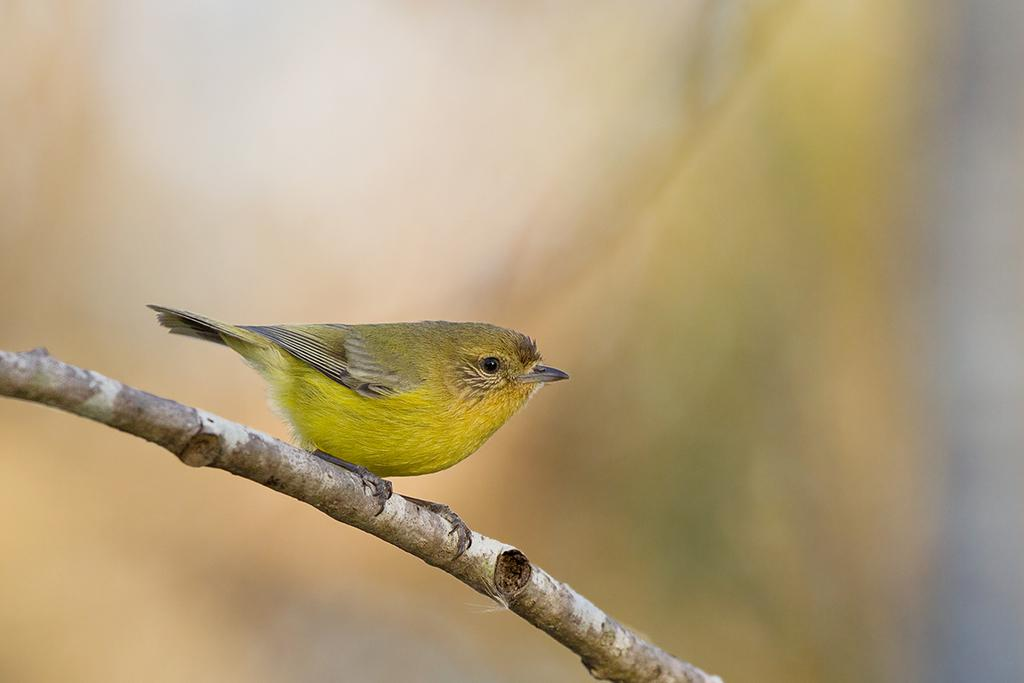What type of bird can be seen in the image? There is a yellow color bird in the image. Where is the bird located in the image? The bird is standing on a branch. Can you describe the quality of the image? The image is blurry. What type of clover is the bird eating in the image? There is no clover present in the image, and the bird is not shown eating anything. 